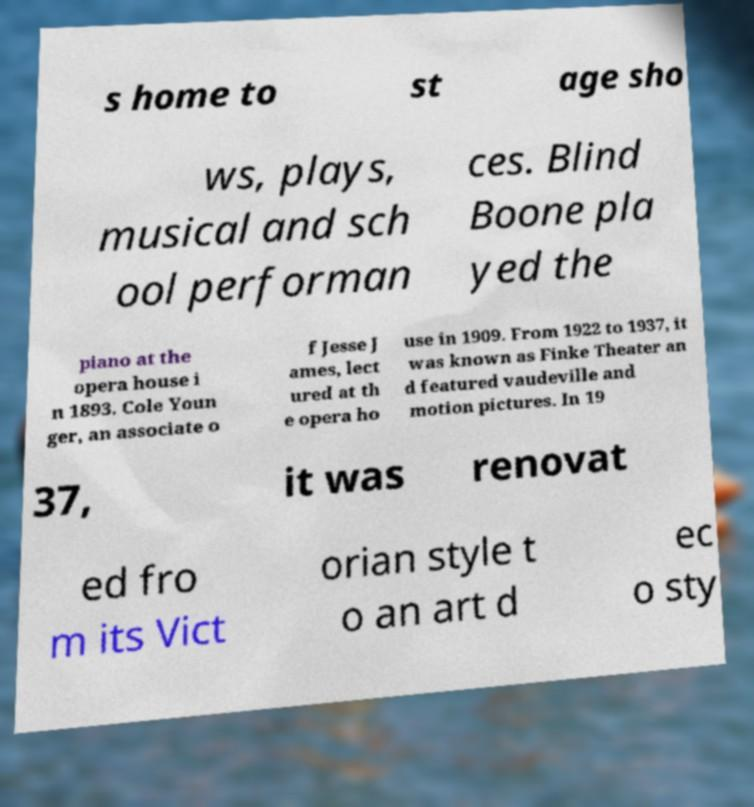For documentation purposes, I need the text within this image transcribed. Could you provide that? s home to st age sho ws, plays, musical and sch ool performan ces. Blind Boone pla yed the piano at the opera house i n 1893. Cole Youn ger, an associate o f Jesse J ames, lect ured at th e opera ho use in 1909. From 1922 to 1937, it was known as Finke Theater an d featured vaudeville and motion pictures. In 19 37, it was renovat ed fro m its Vict orian style t o an art d ec o sty 